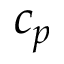<formula> <loc_0><loc_0><loc_500><loc_500>c _ { p }</formula> 